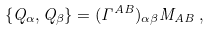Convert formula to latex. <formula><loc_0><loc_0><loc_500><loc_500>\{ Q _ { \alpha } , Q _ { \beta } \} = ( \Gamma ^ { A B } ) _ { \alpha \beta } M _ { A B } \, ,</formula> 